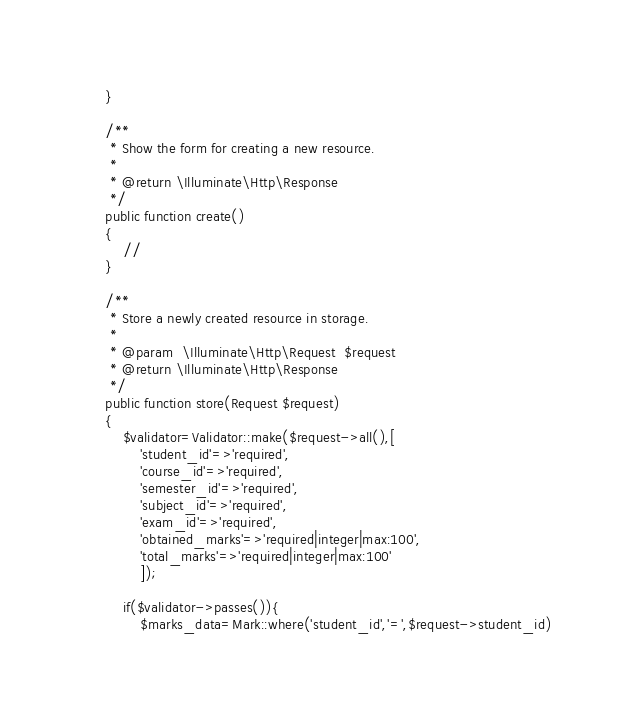Convert code to text. <code><loc_0><loc_0><loc_500><loc_500><_PHP_>    }

    /**
     * Show the form for creating a new resource.
     *
     * @return \Illuminate\Http\Response
     */
    public function create()
    {
        //
    }

    /**
     * Store a newly created resource in storage.
     *
     * @param  \Illuminate\Http\Request  $request
     * @return \Illuminate\Http\Response
     */
    public function store(Request $request)
    {
        $validator=Validator::make($request->all(),[
            'student_id'=>'required',
            'course_id'=>'required',
            'semester_id'=>'required',
            'subject_id'=>'required',
            'exam_id'=>'required',
            'obtained_marks'=>'required|integer|max:100',
            'total_marks'=>'required|integer|max:100'
            ]);
        
        if($validator->passes()){
            $marks_data=Mark::where('student_id','=',$request->student_id)</code> 